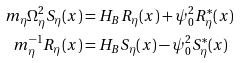Convert formula to latex. <formula><loc_0><loc_0><loc_500><loc_500>m _ { \eta } \Omega _ { \eta } ^ { 2 } S _ { \eta } ( x ) & = H _ { B } R _ { \eta } ( x ) + \psi _ { 0 } ^ { 2 } R _ { \eta } ^ { \ast } ( x ) \\ m _ { \eta } ^ { - 1 } R _ { \eta } ( x ) & = H _ { B } S _ { \eta } ( x ) - \psi _ { 0 } ^ { 2 } S _ { \eta } ^ { \ast } ( x )</formula> 